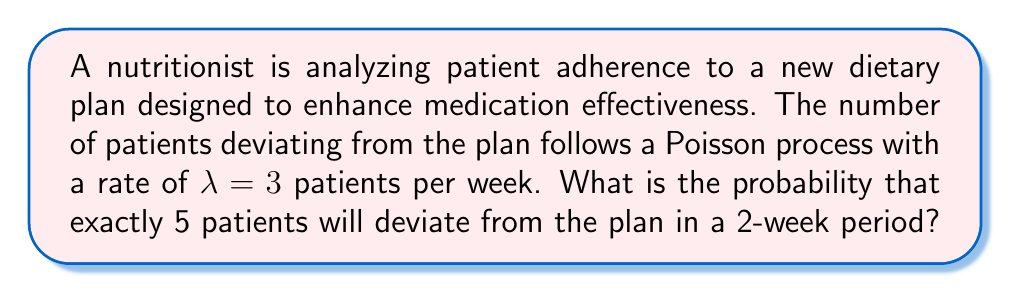Help me with this question. To solve this problem, we'll use the Poisson distribution formula:

$$P(X = k) = \frac{e^{-\lambda t} (\lambda t)^k}{k!}$$

Where:
- $X$ is the number of events (patients deviating)
- $k$ is the specific number of events we're interested in (5 patients)
- $\lambda$ is the rate (3 patients per week)
- $t$ is the time period (2 weeks)

Steps:
1. Calculate $\lambda t$:
   $\lambda t = 3 \text{ patients/week} \times 2 \text{ weeks} = 6 \text{ patients}$

2. Substitute values into the Poisson formula:
   $$P(X = 5) = \frac{e^{-6} (6)^5}{5!}$$

3. Calculate $e^{-6}$:
   $e^{-6} \approx 0.00248$

4. Calculate $6^5$:
   $6^5 = 7776$

5. Calculate $5!$:
   $5! = 5 \times 4 \times 3 \times 2 \times 1 = 120$

6. Put it all together:
   $$P(X = 5) = \frac{0.00248 \times 7776}{120} \approx 0.1606$$

7. Convert to a percentage:
   $0.1606 \times 100\% = 16.06\%$
Answer: 16.06% 